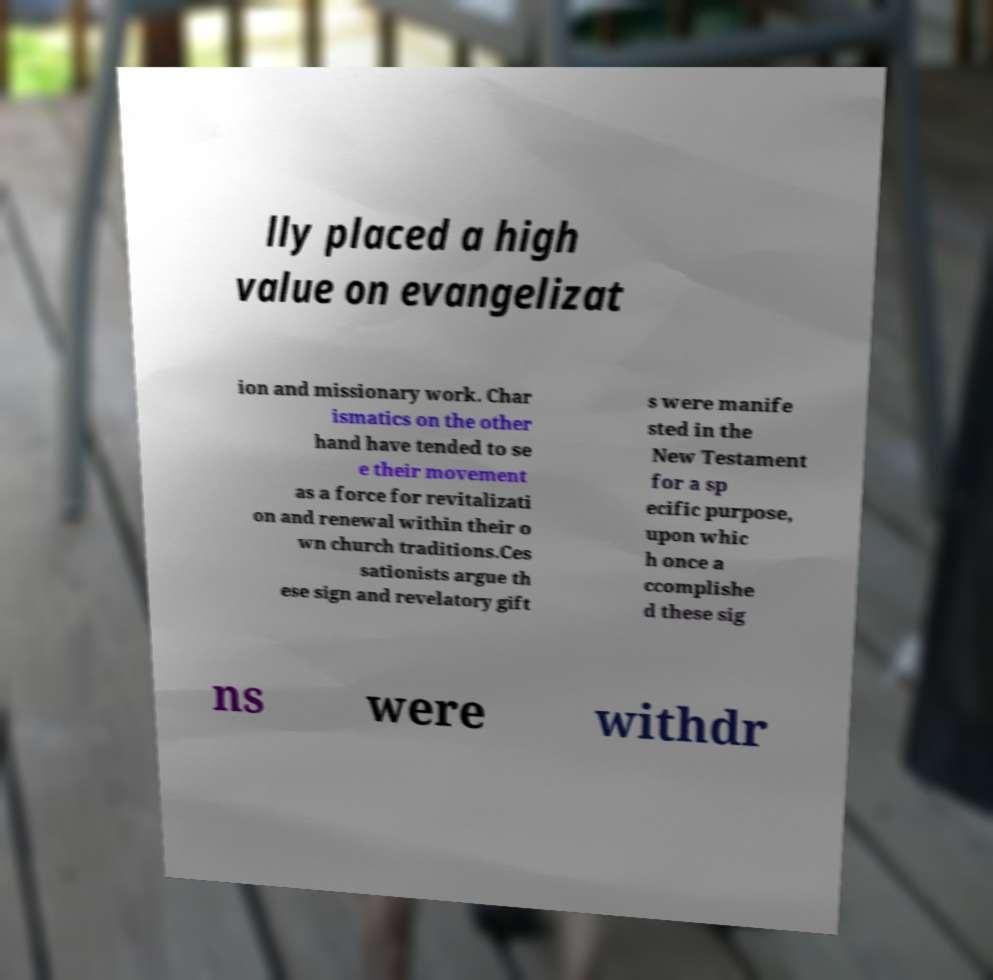Can you read and provide the text displayed in the image?This photo seems to have some interesting text. Can you extract and type it out for me? lly placed a high value on evangelizat ion and missionary work. Char ismatics on the other hand have tended to se e their movement as a force for revitalizati on and renewal within their o wn church traditions.Ces sationists argue th ese sign and revelatory gift s were manife sted in the New Testament for a sp ecific purpose, upon whic h once a ccomplishe d these sig ns were withdr 